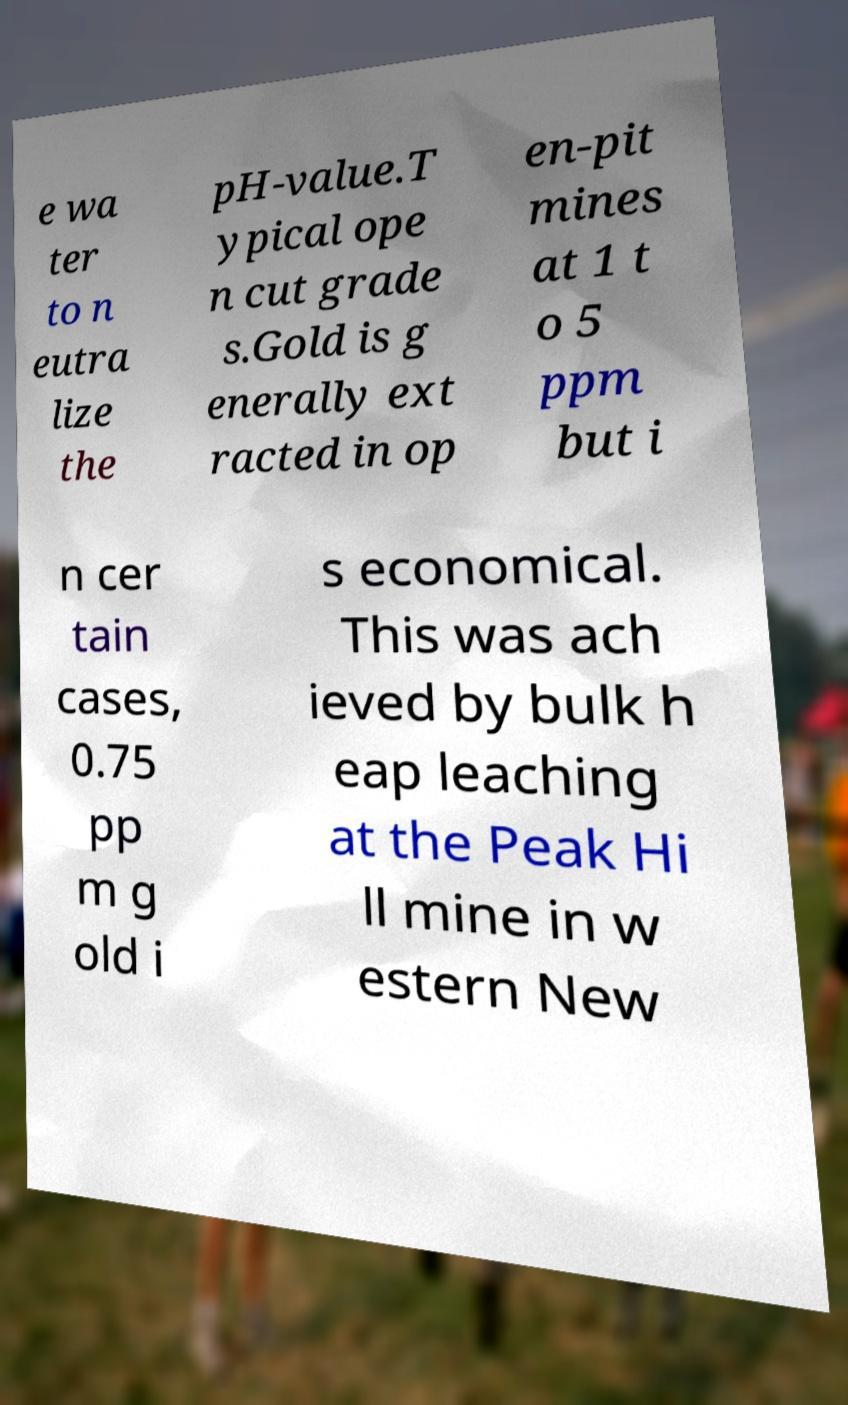I need the written content from this picture converted into text. Can you do that? e wa ter to n eutra lize the pH-value.T ypical ope n cut grade s.Gold is g enerally ext racted in op en-pit mines at 1 t o 5 ppm but i n cer tain cases, 0.75 pp m g old i s economical. This was ach ieved by bulk h eap leaching at the Peak Hi ll mine in w estern New 